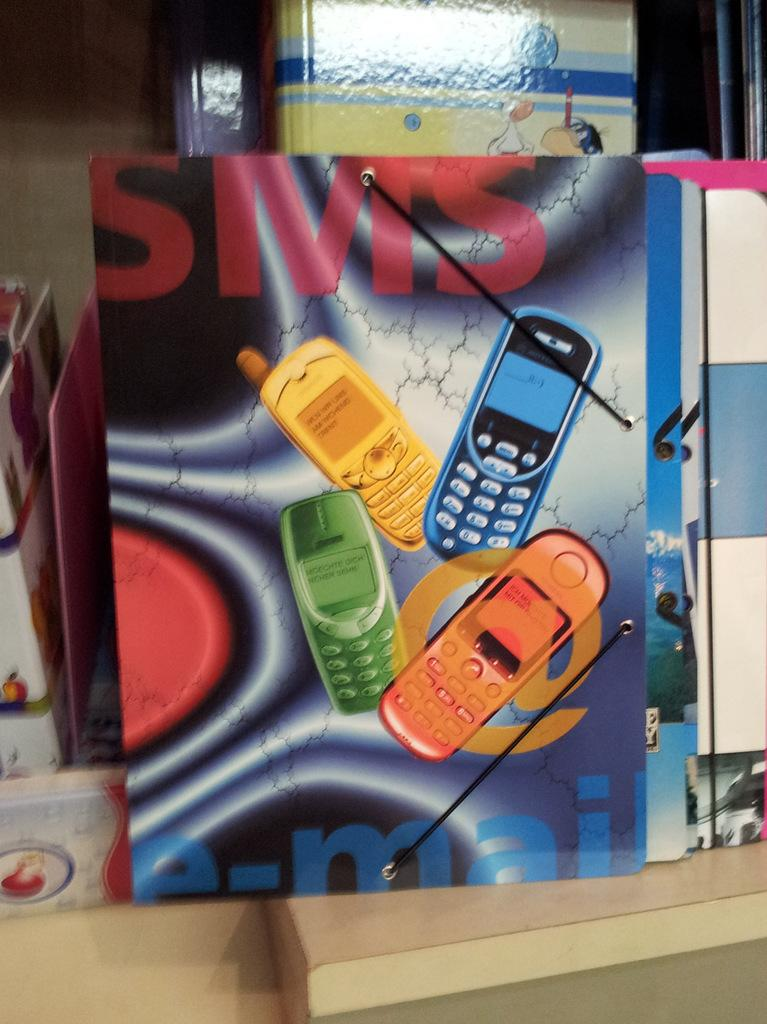<image>
Create a compact narrative representing the image presented. colorful cell phones with the words SMS and e-mail by the side 